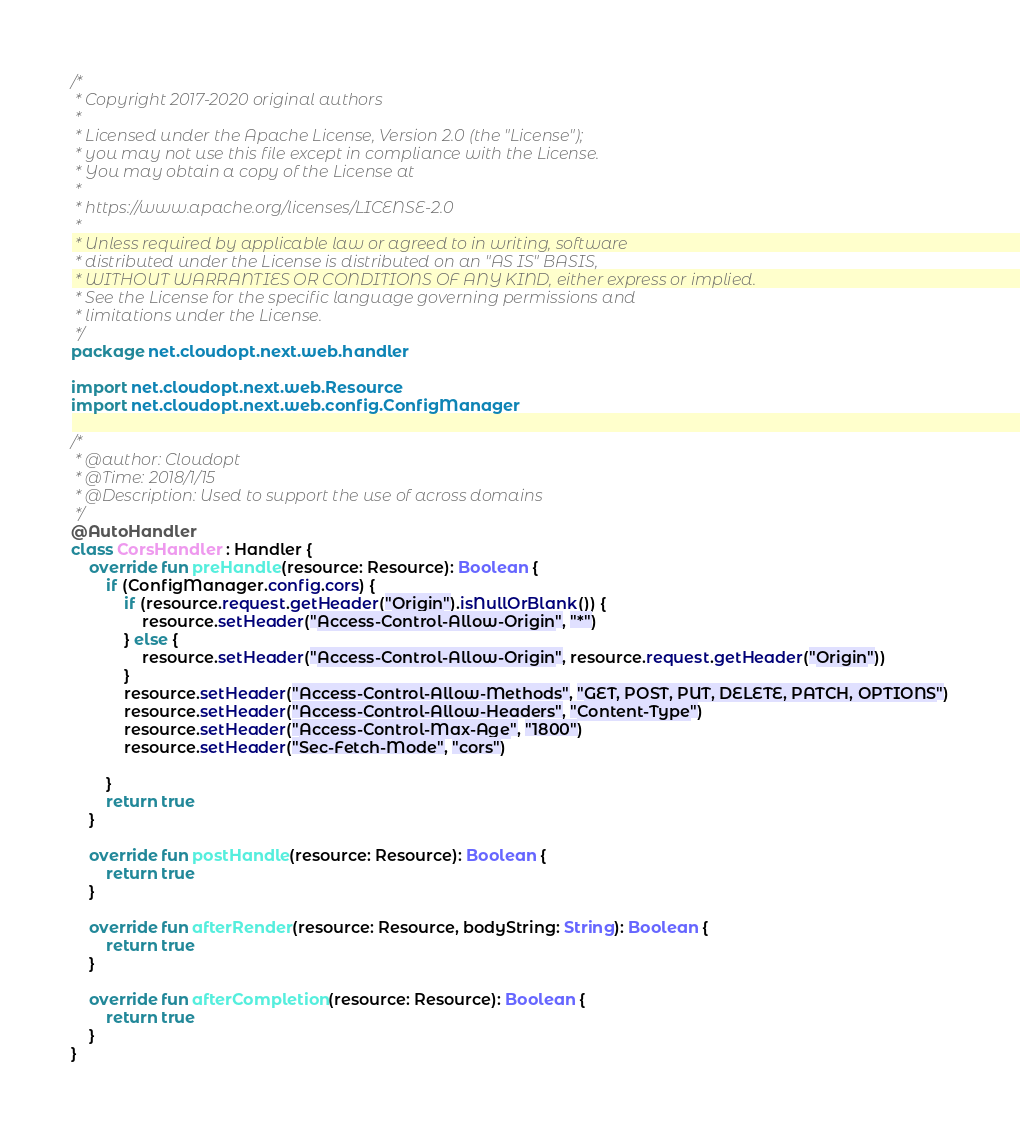<code> <loc_0><loc_0><loc_500><loc_500><_Kotlin_>/*
 * Copyright 2017-2020 original authors
 *
 * Licensed under the Apache License, Version 2.0 (the "License");
 * you may not use this file except in compliance with the License.
 * You may obtain a copy of the License at
 *
 * https://www.apache.org/licenses/LICENSE-2.0
 *
 * Unless required by applicable law or agreed to in writing, software
 * distributed under the License is distributed on an "AS IS" BASIS,
 * WITHOUT WARRANTIES OR CONDITIONS OF ANY KIND, either express or implied.
 * See the License for the specific language governing permissions and
 * limitations under the License.
 */
package net.cloudopt.next.web.handler

import net.cloudopt.next.web.Resource
import net.cloudopt.next.web.config.ConfigManager

/*
 * @author: Cloudopt
 * @Time: 2018/1/15
 * @Description: Used to support the use of across domains
 */
@AutoHandler
class CorsHandler : Handler {
    override fun preHandle(resource: Resource): Boolean {
        if (ConfigManager.config.cors) {
            if (resource.request.getHeader("Origin").isNullOrBlank()) {
                resource.setHeader("Access-Control-Allow-Origin", "*")
            } else {
                resource.setHeader("Access-Control-Allow-Origin", resource.request.getHeader("Origin"))
            }
            resource.setHeader("Access-Control-Allow-Methods", "GET, POST, PUT, DELETE, PATCH, OPTIONS")
            resource.setHeader("Access-Control-Allow-Headers", "Content-Type")
            resource.setHeader("Access-Control-Max-Age", "1800")
            resource.setHeader("Sec-Fetch-Mode", "cors")

        }
        return true
    }

    override fun postHandle(resource: Resource): Boolean {
        return true
    }

    override fun afterRender(resource: Resource, bodyString: String): Boolean {
        return true
    }

    override fun afterCompletion(resource: Resource): Boolean {
        return true
    }
}
</code> 